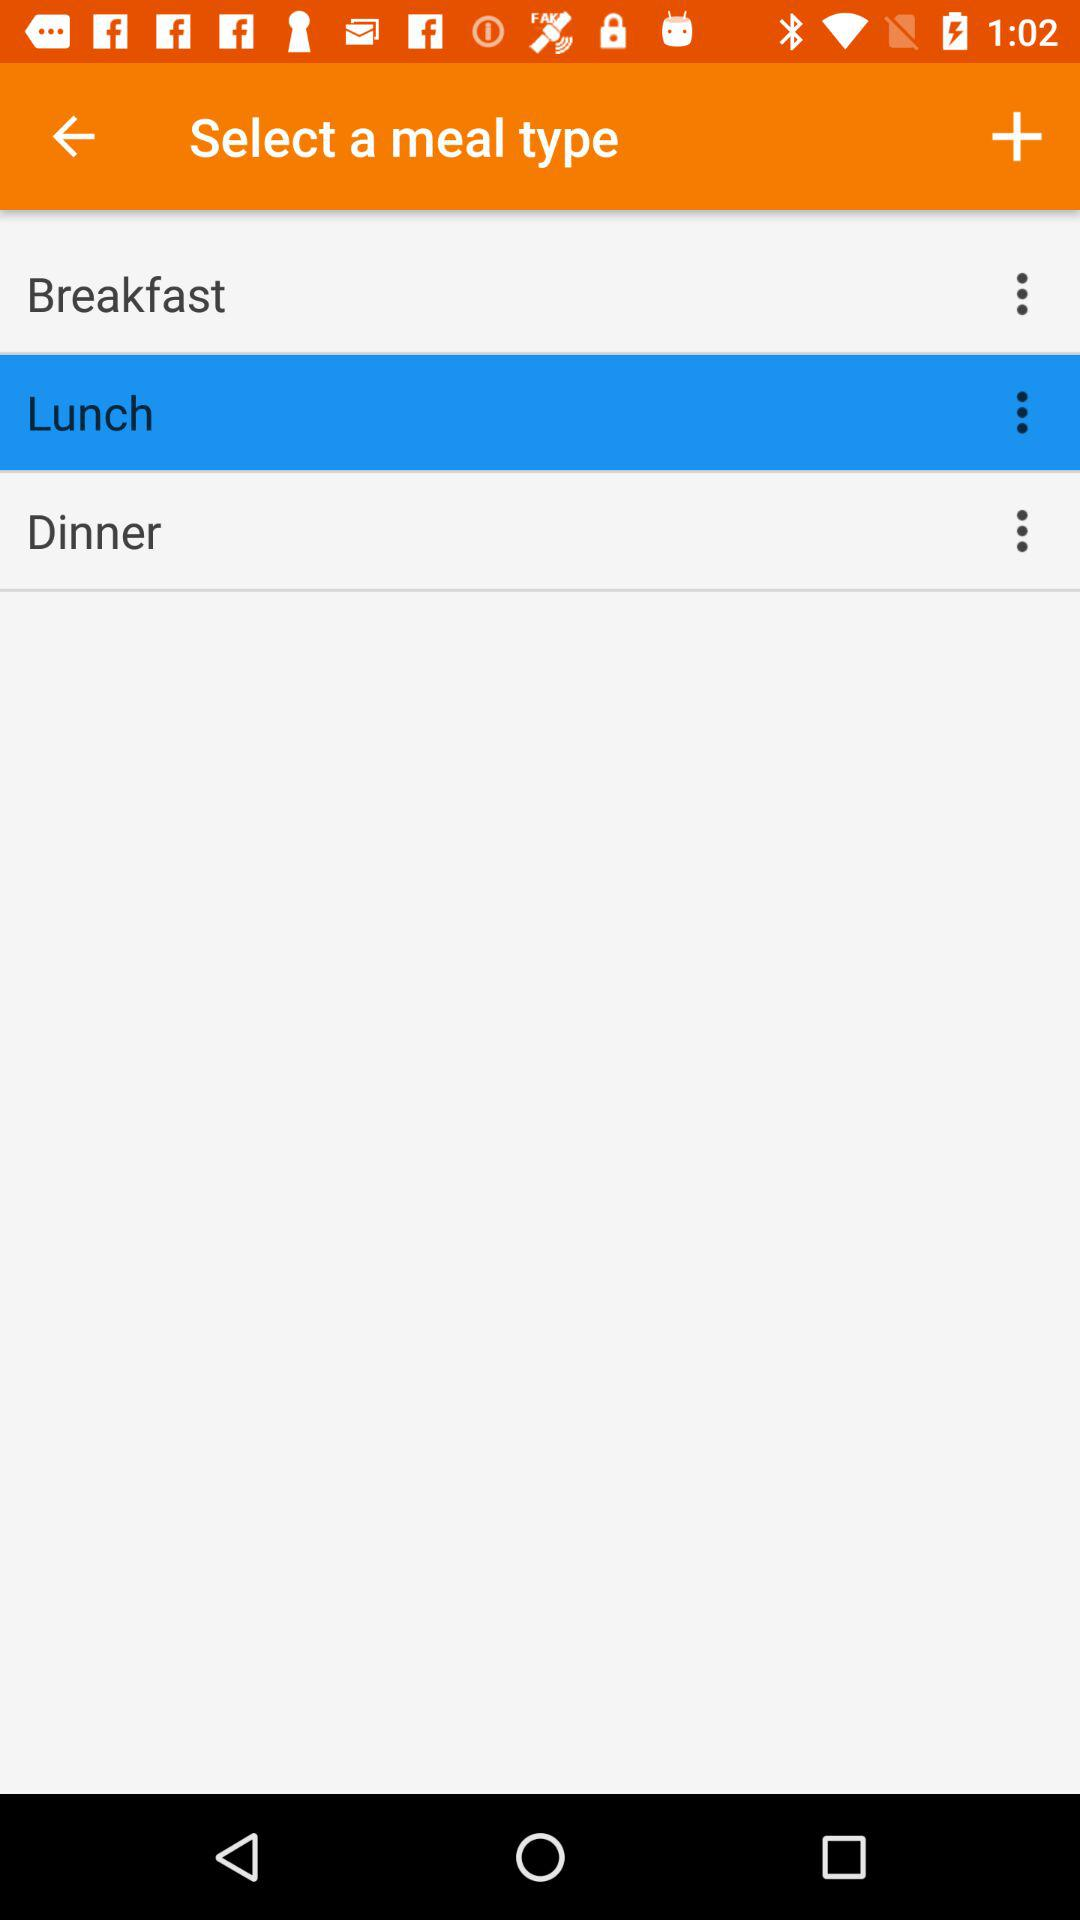What type of meal is selected? The type of meal selected is "Lunch". 